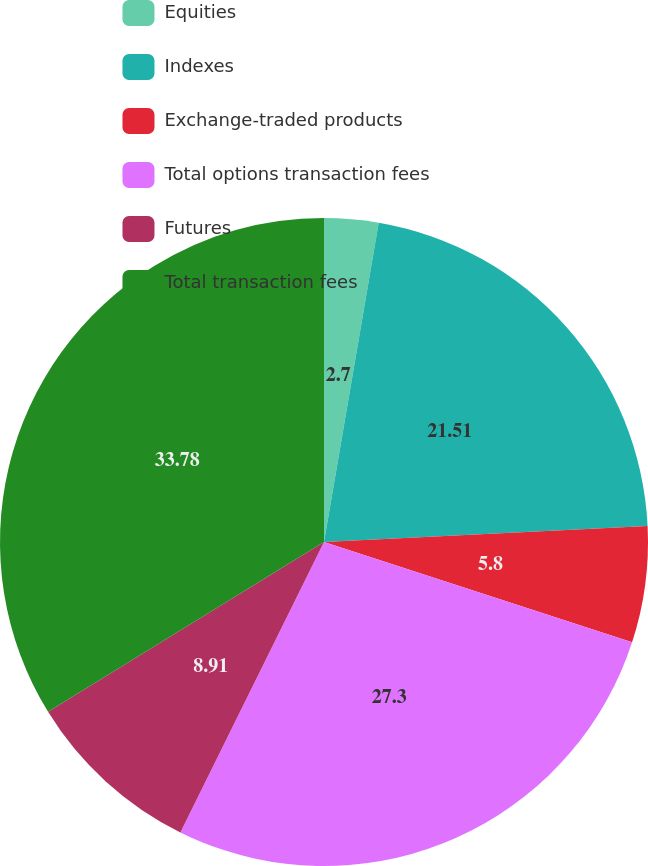<chart> <loc_0><loc_0><loc_500><loc_500><pie_chart><fcel>Equities<fcel>Indexes<fcel>Exchange-traded products<fcel>Total options transaction fees<fcel>Futures<fcel>Total transaction fees<nl><fcel>2.7%<fcel>21.51%<fcel>5.8%<fcel>27.3%<fcel>8.91%<fcel>33.78%<nl></chart> 